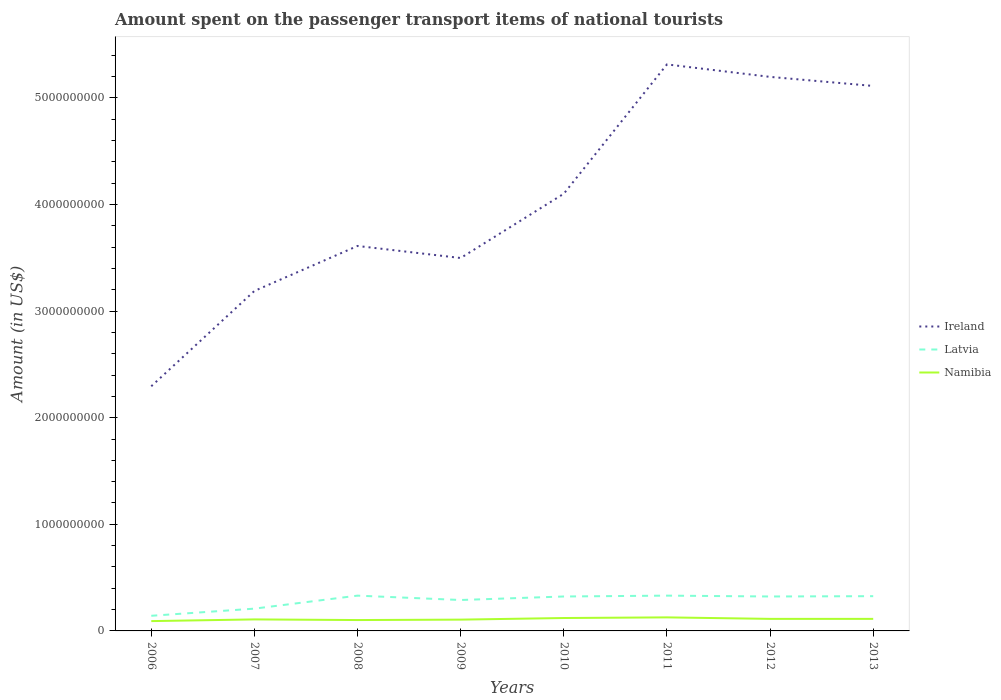Does the line corresponding to Ireland intersect with the line corresponding to Latvia?
Keep it short and to the point. No. Is the number of lines equal to the number of legend labels?
Make the answer very short. Yes. Across all years, what is the maximum amount spent on the passenger transport items of national tourists in Ireland?
Give a very brief answer. 2.30e+09. What is the total amount spent on the passenger transport items of national tourists in Latvia in the graph?
Give a very brief answer. -1.89e+08. What is the difference between the highest and the second highest amount spent on the passenger transport items of national tourists in Ireland?
Offer a very short reply. 3.02e+09. What is the difference between the highest and the lowest amount spent on the passenger transport items of national tourists in Namibia?
Ensure brevity in your answer.  4. How many lines are there?
Ensure brevity in your answer.  3. How many years are there in the graph?
Your response must be concise. 8. Does the graph contain any zero values?
Provide a short and direct response. No. Where does the legend appear in the graph?
Make the answer very short. Center right. How many legend labels are there?
Make the answer very short. 3. How are the legend labels stacked?
Keep it short and to the point. Vertical. What is the title of the graph?
Provide a succinct answer. Amount spent on the passenger transport items of national tourists. Does "Suriname" appear as one of the legend labels in the graph?
Give a very brief answer. No. What is the label or title of the Y-axis?
Your response must be concise. Amount (in US$). What is the Amount (in US$) of Ireland in 2006?
Your answer should be very brief. 2.30e+09. What is the Amount (in US$) in Latvia in 2006?
Make the answer very short. 1.42e+08. What is the Amount (in US$) of Namibia in 2006?
Provide a short and direct response. 9.20e+07. What is the Amount (in US$) of Ireland in 2007?
Your response must be concise. 3.19e+09. What is the Amount (in US$) in Latvia in 2007?
Ensure brevity in your answer.  2.09e+08. What is the Amount (in US$) of Namibia in 2007?
Make the answer very short. 1.08e+08. What is the Amount (in US$) in Ireland in 2008?
Your response must be concise. 3.61e+09. What is the Amount (in US$) in Latvia in 2008?
Keep it short and to the point. 3.31e+08. What is the Amount (in US$) of Namibia in 2008?
Make the answer very short. 1.02e+08. What is the Amount (in US$) in Ireland in 2009?
Provide a succinct answer. 3.50e+09. What is the Amount (in US$) of Latvia in 2009?
Give a very brief answer. 2.90e+08. What is the Amount (in US$) in Namibia in 2009?
Provide a succinct answer. 1.06e+08. What is the Amount (in US$) of Ireland in 2010?
Your answer should be very brief. 4.10e+09. What is the Amount (in US$) of Latvia in 2010?
Offer a very short reply. 3.23e+08. What is the Amount (in US$) in Namibia in 2010?
Make the answer very short. 1.21e+08. What is the Amount (in US$) in Ireland in 2011?
Keep it short and to the point. 5.31e+09. What is the Amount (in US$) in Latvia in 2011?
Ensure brevity in your answer.  3.31e+08. What is the Amount (in US$) in Namibia in 2011?
Your answer should be compact. 1.27e+08. What is the Amount (in US$) of Ireland in 2012?
Make the answer very short. 5.20e+09. What is the Amount (in US$) of Latvia in 2012?
Provide a short and direct response. 3.23e+08. What is the Amount (in US$) in Namibia in 2012?
Ensure brevity in your answer.  1.13e+08. What is the Amount (in US$) in Ireland in 2013?
Keep it short and to the point. 5.11e+09. What is the Amount (in US$) in Latvia in 2013?
Provide a succinct answer. 3.26e+08. What is the Amount (in US$) in Namibia in 2013?
Give a very brief answer. 1.13e+08. Across all years, what is the maximum Amount (in US$) in Ireland?
Your answer should be compact. 5.31e+09. Across all years, what is the maximum Amount (in US$) of Latvia?
Your answer should be very brief. 3.31e+08. Across all years, what is the maximum Amount (in US$) of Namibia?
Give a very brief answer. 1.27e+08. Across all years, what is the minimum Amount (in US$) in Ireland?
Provide a short and direct response. 2.30e+09. Across all years, what is the minimum Amount (in US$) of Latvia?
Your answer should be very brief. 1.42e+08. Across all years, what is the minimum Amount (in US$) in Namibia?
Keep it short and to the point. 9.20e+07. What is the total Amount (in US$) of Ireland in the graph?
Your answer should be compact. 3.23e+1. What is the total Amount (in US$) of Latvia in the graph?
Your answer should be very brief. 2.28e+09. What is the total Amount (in US$) in Namibia in the graph?
Ensure brevity in your answer.  8.82e+08. What is the difference between the Amount (in US$) in Ireland in 2006 and that in 2007?
Offer a terse response. -8.94e+08. What is the difference between the Amount (in US$) of Latvia in 2006 and that in 2007?
Your response must be concise. -6.70e+07. What is the difference between the Amount (in US$) of Namibia in 2006 and that in 2007?
Your response must be concise. -1.60e+07. What is the difference between the Amount (in US$) in Ireland in 2006 and that in 2008?
Make the answer very short. -1.32e+09. What is the difference between the Amount (in US$) in Latvia in 2006 and that in 2008?
Ensure brevity in your answer.  -1.89e+08. What is the difference between the Amount (in US$) of Namibia in 2006 and that in 2008?
Ensure brevity in your answer.  -1.00e+07. What is the difference between the Amount (in US$) in Ireland in 2006 and that in 2009?
Make the answer very short. -1.20e+09. What is the difference between the Amount (in US$) of Latvia in 2006 and that in 2009?
Ensure brevity in your answer.  -1.48e+08. What is the difference between the Amount (in US$) of Namibia in 2006 and that in 2009?
Your response must be concise. -1.40e+07. What is the difference between the Amount (in US$) in Ireland in 2006 and that in 2010?
Make the answer very short. -1.81e+09. What is the difference between the Amount (in US$) of Latvia in 2006 and that in 2010?
Give a very brief answer. -1.81e+08. What is the difference between the Amount (in US$) in Namibia in 2006 and that in 2010?
Keep it short and to the point. -2.90e+07. What is the difference between the Amount (in US$) of Ireland in 2006 and that in 2011?
Offer a terse response. -3.02e+09. What is the difference between the Amount (in US$) of Latvia in 2006 and that in 2011?
Your answer should be compact. -1.89e+08. What is the difference between the Amount (in US$) in Namibia in 2006 and that in 2011?
Make the answer very short. -3.50e+07. What is the difference between the Amount (in US$) in Ireland in 2006 and that in 2012?
Provide a short and direct response. -2.90e+09. What is the difference between the Amount (in US$) in Latvia in 2006 and that in 2012?
Give a very brief answer. -1.81e+08. What is the difference between the Amount (in US$) of Namibia in 2006 and that in 2012?
Keep it short and to the point. -2.10e+07. What is the difference between the Amount (in US$) of Ireland in 2006 and that in 2013?
Provide a short and direct response. -2.82e+09. What is the difference between the Amount (in US$) of Latvia in 2006 and that in 2013?
Keep it short and to the point. -1.84e+08. What is the difference between the Amount (in US$) in Namibia in 2006 and that in 2013?
Keep it short and to the point. -2.10e+07. What is the difference between the Amount (in US$) of Ireland in 2007 and that in 2008?
Ensure brevity in your answer.  -4.22e+08. What is the difference between the Amount (in US$) in Latvia in 2007 and that in 2008?
Make the answer very short. -1.22e+08. What is the difference between the Amount (in US$) in Namibia in 2007 and that in 2008?
Offer a terse response. 6.00e+06. What is the difference between the Amount (in US$) in Ireland in 2007 and that in 2009?
Your answer should be very brief. -3.09e+08. What is the difference between the Amount (in US$) in Latvia in 2007 and that in 2009?
Provide a succinct answer. -8.10e+07. What is the difference between the Amount (in US$) of Ireland in 2007 and that in 2010?
Provide a short and direct response. -9.12e+08. What is the difference between the Amount (in US$) of Latvia in 2007 and that in 2010?
Offer a very short reply. -1.14e+08. What is the difference between the Amount (in US$) in Namibia in 2007 and that in 2010?
Keep it short and to the point. -1.30e+07. What is the difference between the Amount (in US$) of Ireland in 2007 and that in 2011?
Your answer should be compact. -2.12e+09. What is the difference between the Amount (in US$) of Latvia in 2007 and that in 2011?
Offer a very short reply. -1.22e+08. What is the difference between the Amount (in US$) in Namibia in 2007 and that in 2011?
Provide a succinct answer. -1.90e+07. What is the difference between the Amount (in US$) of Ireland in 2007 and that in 2012?
Make the answer very short. -2.01e+09. What is the difference between the Amount (in US$) in Latvia in 2007 and that in 2012?
Make the answer very short. -1.14e+08. What is the difference between the Amount (in US$) of Namibia in 2007 and that in 2012?
Provide a short and direct response. -5.00e+06. What is the difference between the Amount (in US$) of Ireland in 2007 and that in 2013?
Offer a very short reply. -1.92e+09. What is the difference between the Amount (in US$) in Latvia in 2007 and that in 2013?
Provide a succinct answer. -1.17e+08. What is the difference between the Amount (in US$) in Namibia in 2007 and that in 2013?
Provide a short and direct response. -5.00e+06. What is the difference between the Amount (in US$) of Ireland in 2008 and that in 2009?
Make the answer very short. 1.13e+08. What is the difference between the Amount (in US$) in Latvia in 2008 and that in 2009?
Keep it short and to the point. 4.10e+07. What is the difference between the Amount (in US$) in Namibia in 2008 and that in 2009?
Make the answer very short. -4.00e+06. What is the difference between the Amount (in US$) of Ireland in 2008 and that in 2010?
Your answer should be very brief. -4.90e+08. What is the difference between the Amount (in US$) in Namibia in 2008 and that in 2010?
Make the answer very short. -1.90e+07. What is the difference between the Amount (in US$) of Ireland in 2008 and that in 2011?
Ensure brevity in your answer.  -1.70e+09. What is the difference between the Amount (in US$) of Namibia in 2008 and that in 2011?
Make the answer very short. -2.50e+07. What is the difference between the Amount (in US$) of Ireland in 2008 and that in 2012?
Your answer should be compact. -1.59e+09. What is the difference between the Amount (in US$) in Namibia in 2008 and that in 2012?
Ensure brevity in your answer.  -1.10e+07. What is the difference between the Amount (in US$) of Ireland in 2008 and that in 2013?
Ensure brevity in your answer.  -1.50e+09. What is the difference between the Amount (in US$) of Latvia in 2008 and that in 2013?
Make the answer very short. 5.00e+06. What is the difference between the Amount (in US$) in Namibia in 2008 and that in 2013?
Your response must be concise. -1.10e+07. What is the difference between the Amount (in US$) in Ireland in 2009 and that in 2010?
Ensure brevity in your answer.  -6.03e+08. What is the difference between the Amount (in US$) in Latvia in 2009 and that in 2010?
Give a very brief answer. -3.30e+07. What is the difference between the Amount (in US$) of Namibia in 2009 and that in 2010?
Provide a succinct answer. -1.50e+07. What is the difference between the Amount (in US$) in Ireland in 2009 and that in 2011?
Provide a succinct answer. -1.82e+09. What is the difference between the Amount (in US$) in Latvia in 2009 and that in 2011?
Offer a terse response. -4.10e+07. What is the difference between the Amount (in US$) of Namibia in 2009 and that in 2011?
Keep it short and to the point. -2.10e+07. What is the difference between the Amount (in US$) of Ireland in 2009 and that in 2012?
Offer a terse response. -1.70e+09. What is the difference between the Amount (in US$) of Latvia in 2009 and that in 2012?
Your answer should be compact. -3.30e+07. What is the difference between the Amount (in US$) in Namibia in 2009 and that in 2012?
Give a very brief answer. -7.00e+06. What is the difference between the Amount (in US$) of Ireland in 2009 and that in 2013?
Your answer should be compact. -1.61e+09. What is the difference between the Amount (in US$) of Latvia in 2009 and that in 2013?
Your response must be concise. -3.60e+07. What is the difference between the Amount (in US$) of Namibia in 2009 and that in 2013?
Your response must be concise. -7.00e+06. What is the difference between the Amount (in US$) in Ireland in 2010 and that in 2011?
Keep it short and to the point. -1.21e+09. What is the difference between the Amount (in US$) of Latvia in 2010 and that in 2011?
Ensure brevity in your answer.  -8.00e+06. What is the difference between the Amount (in US$) in Namibia in 2010 and that in 2011?
Your answer should be compact. -6.00e+06. What is the difference between the Amount (in US$) in Ireland in 2010 and that in 2012?
Keep it short and to the point. -1.10e+09. What is the difference between the Amount (in US$) in Latvia in 2010 and that in 2012?
Ensure brevity in your answer.  0. What is the difference between the Amount (in US$) of Ireland in 2010 and that in 2013?
Your answer should be very brief. -1.01e+09. What is the difference between the Amount (in US$) in Latvia in 2010 and that in 2013?
Offer a terse response. -3.00e+06. What is the difference between the Amount (in US$) of Ireland in 2011 and that in 2012?
Provide a succinct answer. 1.17e+08. What is the difference between the Amount (in US$) of Latvia in 2011 and that in 2012?
Your response must be concise. 8.00e+06. What is the difference between the Amount (in US$) of Namibia in 2011 and that in 2012?
Provide a short and direct response. 1.40e+07. What is the difference between the Amount (in US$) in Ireland in 2011 and that in 2013?
Offer a very short reply. 2.02e+08. What is the difference between the Amount (in US$) of Latvia in 2011 and that in 2013?
Give a very brief answer. 5.00e+06. What is the difference between the Amount (in US$) of Namibia in 2011 and that in 2013?
Offer a very short reply. 1.40e+07. What is the difference between the Amount (in US$) of Ireland in 2012 and that in 2013?
Your answer should be compact. 8.50e+07. What is the difference between the Amount (in US$) in Latvia in 2012 and that in 2013?
Your answer should be compact. -3.00e+06. What is the difference between the Amount (in US$) in Ireland in 2006 and the Amount (in US$) in Latvia in 2007?
Make the answer very short. 2.09e+09. What is the difference between the Amount (in US$) in Ireland in 2006 and the Amount (in US$) in Namibia in 2007?
Your answer should be compact. 2.19e+09. What is the difference between the Amount (in US$) in Latvia in 2006 and the Amount (in US$) in Namibia in 2007?
Make the answer very short. 3.40e+07. What is the difference between the Amount (in US$) in Ireland in 2006 and the Amount (in US$) in Latvia in 2008?
Provide a short and direct response. 1.96e+09. What is the difference between the Amount (in US$) of Ireland in 2006 and the Amount (in US$) of Namibia in 2008?
Your response must be concise. 2.19e+09. What is the difference between the Amount (in US$) in Latvia in 2006 and the Amount (in US$) in Namibia in 2008?
Provide a succinct answer. 4.00e+07. What is the difference between the Amount (in US$) in Ireland in 2006 and the Amount (in US$) in Latvia in 2009?
Give a very brief answer. 2.00e+09. What is the difference between the Amount (in US$) in Ireland in 2006 and the Amount (in US$) in Namibia in 2009?
Keep it short and to the point. 2.19e+09. What is the difference between the Amount (in US$) of Latvia in 2006 and the Amount (in US$) of Namibia in 2009?
Make the answer very short. 3.60e+07. What is the difference between the Amount (in US$) of Ireland in 2006 and the Amount (in US$) of Latvia in 2010?
Offer a terse response. 1.97e+09. What is the difference between the Amount (in US$) of Ireland in 2006 and the Amount (in US$) of Namibia in 2010?
Provide a succinct answer. 2.17e+09. What is the difference between the Amount (in US$) of Latvia in 2006 and the Amount (in US$) of Namibia in 2010?
Offer a very short reply. 2.10e+07. What is the difference between the Amount (in US$) in Ireland in 2006 and the Amount (in US$) in Latvia in 2011?
Give a very brief answer. 1.96e+09. What is the difference between the Amount (in US$) of Ireland in 2006 and the Amount (in US$) of Namibia in 2011?
Provide a short and direct response. 2.17e+09. What is the difference between the Amount (in US$) of Latvia in 2006 and the Amount (in US$) of Namibia in 2011?
Offer a very short reply. 1.50e+07. What is the difference between the Amount (in US$) in Ireland in 2006 and the Amount (in US$) in Latvia in 2012?
Provide a short and direct response. 1.97e+09. What is the difference between the Amount (in US$) of Ireland in 2006 and the Amount (in US$) of Namibia in 2012?
Give a very brief answer. 2.18e+09. What is the difference between the Amount (in US$) in Latvia in 2006 and the Amount (in US$) in Namibia in 2012?
Offer a terse response. 2.90e+07. What is the difference between the Amount (in US$) in Ireland in 2006 and the Amount (in US$) in Latvia in 2013?
Make the answer very short. 1.97e+09. What is the difference between the Amount (in US$) of Ireland in 2006 and the Amount (in US$) of Namibia in 2013?
Keep it short and to the point. 2.18e+09. What is the difference between the Amount (in US$) in Latvia in 2006 and the Amount (in US$) in Namibia in 2013?
Give a very brief answer. 2.90e+07. What is the difference between the Amount (in US$) of Ireland in 2007 and the Amount (in US$) of Latvia in 2008?
Give a very brief answer. 2.86e+09. What is the difference between the Amount (in US$) in Ireland in 2007 and the Amount (in US$) in Namibia in 2008?
Your answer should be very brief. 3.09e+09. What is the difference between the Amount (in US$) of Latvia in 2007 and the Amount (in US$) of Namibia in 2008?
Provide a short and direct response. 1.07e+08. What is the difference between the Amount (in US$) of Ireland in 2007 and the Amount (in US$) of Latvia in 2009?
Your answer should be very brief. 2.90e+09. What is the difference between the Amount (in US$) of Ireland in 2007 and the Amount (in US$) of Namibia in 2009?
Ensure brevity in your answer.  3.08e+09. What is the difference between the Amount (in US$) of Latvia in 2007 and the Amount (in US$) of Namibia in 2009?
Your response must be concise. 1.03e+08. What is the difference between the Amount (in US$) in Ireland in 2007 and the Amount (in US$) in Latvia in 2010?
Your response must be concise. 2.87e+09. What is the difference between the Amount (in US$) of Ireland in 2007 and the Amount (in US$) of Namibia in 2010?
Give a very brief answer. 3.07e+09. What is the difference between the Amount (in US$) of Latvia in 2007 and the Amount (in US$) of Namibia in 2010?
Ensure brevity in your answer.  8.80e+07. What is the difference between the Amount (in US$) of Ireland in 2007 and the Amount (in US$) of Latvia in 2011?
Your answer should be compact. 2.86e+09. What is the difference between the Amount (in US$) in Ireland in 2007 and the Amount (in US$) in Namibia in 2011?
Ensure brevity in your answer.  3.06e+09. What is the difference between the Amount (in US$) in Latvia in 2007 and the Amount (in US$) in Namibia in 2011?
Provide a short and direct response. 8.20e+07. What is the difference between the Amount (in US$) of Ireland in 2007 and the Amount (in US$) of Latvia in 2012?
Provide a short and direct response. 2.87e+09. What is the difference between the Amount (in US$) in Ireland in 2007 and the Amount (in US$) in Namibia in 2012?
Your answer should be very brief. 3.08e+09. What is the difference between the Amount (in US$) in Latvia in 2007 and the Amount (in US$) in Namibia in 2012?
Your response must be concise. 9.60e+07. What is the difference between the Amount (in US$) of Ireland in 2007 and the Amount (in US$) of Latvia in 2013?
Offer a very short reply. 2.86e+09. What is the difference between the Amount (in US$) in Ireland in 2007 and the Amount (in US$) in Namibia in 2013?
Offer a very short reply. 3.08e+09. What is the difference between the Amount (in US$) of Latvia in 2007 and the Amount (in US$) of Namibia in 2013?
Your answer should be very brief. 9.60e+07. What is the difference between the Amount (in US$) of Ireland in 2008 and the Amount (in US$) of Latvia in 2009?
Your answer should be compact. 3.32e+09. What is the difference between the Amount (in US$) in Ireland in 2008 and the Amount (in US$) in Namibia in 2009?
Offer a very short reply. 3.50e+09. What is the difference between the Amount (in US$) of Latvia in 2008 and the Amount (in US$) of Namibia in 2009?
Your answer should be compact. 2.25e+08. What is the difference between the Amount (in US$) of Ireland in 2008 and the Amount (in US$) of Latvia in 2010?
Ensure brevity in your answer.  3.29e+09. What is the difference between the Amount (in US$) of Ireland in 2008 and the Amount (in US$) of Namibia in 2010?
Give a very brief answer. 3.49e+09. What is the difference between the Amount (in US$) of Latvia in 2008 and the Amount (in US$) of Namibia in 2010?
Give a very brief answer. 2.10e+08. What is the difference between the Amount (in US$) of Ireland in 2008 and the Amount (in US$) of Latvia in 2011?
Offer a terse response. 3.28e+09. What is the difference between the Amount (in US$) in Ireland in 2008 and the Amount (in US$) in Namibia in 2011?
Provide a succinct answer. 3.48e+09. What is the difference between the Amount (in US$) in Latvia in 2008 and the Amount (in US$) in Namibia in 2011?
Offer a very short reply. 2.04e+08. What is the difference between the Amount (in US$) of Ireland in 2008 and the Amount (in US$) of Latvia in 2012?
Your answer should be very brief. 3.29e+09. What is the difference between the Amount (in US$) of Ireland in 2008 and the Amount (in US$) of Namibia in 2012?
Provide a short and direct response. 3.50e+09. What is the difference between the Amount (in US$) in Latvia in 2008 and the Amount (in US$) in Namibia in 2012?
Your response must be concise. 2.18e+08. What is the difference between the Amount (in US$) in Ireland in 2008 and the Amount (in US$) in Latvia in 2013?
Provide a succinct answer. 3.28e+09. What is the difference between the Amount (in US$) in Ireland in 2008 and the Amount (in US$) in Namibia in 2013?
Make the answer very short. 3.50e+09. What is the difference between the Amount (in US$) of Latvia in 2008 and the Amount (in US$) of Namibia in 2013?
Make the answer very short. 2.18e+08. What is the difference between the Amount (in US$) in Ireland in 2009 and the Amount (in US$) in Latvia in 2010?
Ensure brevity in your answer.  3.18e+09. What is the difference between the Amount (in US$) of Ireland in 2009 and the Amount (in US$) of Namibia in 2010?
Ensure brevity in your answer.  3.38e+09. What is the difference between the Amount (in US$) in Latvia in 2009 and the Amount (in US$) in Namibia in 2010?
Make the answer very short. 1.69e+08. What is the difference between the Amount (in US$) of Ireland in 2009 and the Amount (in US$) of Latvia in 2011?
Offer a very short reply. 3.17e+09. What is the difference between the Amount (in US$) in Ireland in 2009 and the Amount (in US$) in Namibia in 2011?
Give a very brief answer. 3.37e+09. What is the difference between the Amount (in US$) of Latvia in 2009 and the Amount (in US$) of Namibia in 2011?
Your answer should be compact. 1.63e+08. What is the difference between the Amount (in US$) of Ireland in 2009 and the Amount (in US$) of Latvia in 2012?
Your response must be concise. 3.18e+09. What is the difference between the Amount (in US$) of Ireland in 2009 and the Amount (in US$) of Namibia in 2012?
Your response must be concise. 3.38e+09. What is the difference between the Amount (in US$) in Latvia in 2009 and the Amount (in US$) in Namibia in 2012?
Your answer should be very brief. 1.77e+08. What is the difference between the Amount (in US$) in Ireland in 2009 and the Amount (in US$) in Latvia in 2013?
Offer a very short reply. 3.17e+09. What is the difference between the Amount (in US$) of Ireland in 2009 and the Amount (in US$) of Namibia in 2013?
Provide a succinct answer. 3.38e+09. What is the difference between the Amount (in US$) of Latvia in 2009 and the Amount (in US$) of Namibia in 2013?
Offer a very short reply. 1.77e+08. What is the difference between the Amount (in US$) in Ireland in 2010 and the Amount (in US$) in Latvia in 2011?
Make the answer very short. 3.77e+09. What is the difference between the Amount (in US$) of Ireland in 2010 and the Amount (in US$) of Namibia in 2011?
Provide a short and direct response. 3.97e+09. What is the difference between the Amount (in US$) in Latvia in 2010 and the Amount (in US$) in Namibia in 2011?
Ensure brevity in your answer.  1.96e+08. What is the difference between the Amount (in US$) in Ireland in 2010 and the Amount (in US$) in Latvia in 2012?
Provide a short and direct response. 3.78e+09. What is the difference between the Amount (in US$) in Ireland in 2010 and the Amount (in US$) in Namibia in 2012?
Keep it short and to the point. 3.99e+09. What is the difference between the Amount (in US$) of Latvia in 2010 and the Amount (in US$) of Namibia in 2012?
Give a very brief answer. 2.10e+08. What is the difference between the Amount (in US$) of Ireland in 2010 and the Amount (in US$) of Latvia in 2013?
Offer a very short reply. 3.78e+09. What is the difference between the Amount (in US$) of Ireland in 2010 and the Amount (in US$) of Namibia in 2013?
Keep it short and to the point. 3.99e+09. What is the difference between the Amount (in US$) of Latvia in 2010 and the Amount (in US$) of Namibia in 2013?
Provide a succinct answer. 2.10e+08. What is the difference between the Amount (in US$) of Ireland in 2011 and the Amount (in US$) of Latvia in 2012?
Provide a short and direct response. 4.99e+09. What is the difference between the Amount (in US$) in Ireland in 2011 and the Amount (in US$) in Namibia in 2012?
Offer a terse response. 5.20e+09. What is the difference between the Amount (in US$) of Latvia in 2011 and the Amount (in US$) of Namibia in 2012?
Your answer should be compact. 2.18e+08. What is the difference between the Amount (in US$) of Ireland in 2011 and the Amount (in US$) of Latvia in 2013?
Offer a very short reply. 4.99e+09. What is the difference between the Amount (in US$) of Ireland in 2011 and the Amount (in US$) of Namibia in 2013?
Offer a terse response. 5.20e+09. What is the difference between the Amount (in US$) in Latvia in 2011 and the Amount (in US$) in Namibia in 2013?
Offer a very short reply. 2.18e+08. What is the difference between the Amount (in US$) of Ireland in 2012 and the Amount (in US$) of Latvia in 2013?
Ensure brevity in your answer.  4.87e+09. What is the difference between the Amount (in US$) of Ireland in 2012 and the Amount (in US$) of Namibia in 2013?
Make the answer very short. 5.08e+09. What is the difference between the Amount (in US$) of Latvia in 2012 and the Amount (in US$) of Namibia in 2013?
Offer a very short reply. 2.10e+08. What is the average Amount (in US$) in Ireland per year?
Give a very brief answer. 4.04e+09. What is the average Amount (in US$) of Latvia per year?
Offer a terse response. 2.84e+08. What is the average Amount (in US$) of Namibia per year?
Offer a very short reply. 1.10e+08. In the year 2006, what is the difference between the Amount (in US$) in Ireland and Amount (in US$) in Latvia?
Your answer should be very brief. 2.15e+09. In the year 2006, what is the difference between the Amount (in US$) of Ireland and Amount (in US$) of Namibia?
Make the answer very short. 2.20e+09. In the year 2007, what is the difference between the Amount (in US$) in Ireland and Amount (in US$) in Latvia?
Your answer should be very brief. 2.98e+09. In the year 2007, what is the difference between the Amount (in US$) of Ireland and Amount (in US$) of Namibia?
Offer a terse response. 3.08e+09. In the year 2007, what is the difference between the Amount (in US$) of Latvia and Amount (in US$) of Namibia?
Your answer should be compact. 1.01e+08. In the year 2008, what is the difference between the Amount (in US$) of Ireland and Amount (in US$) of Latvia?
Your answer should be very brief. 3.28e+09. In the year 2008, what is the difference between the Amount (in US$) in Ireland and Amount (in US$) in Namibia?
Ensure brevity in your answer.  3.51e+09. In the year 2008, what is the difference between the Amount (in US$) in Latvia and Amount (in US$) in Namibia?
Ensure brevity in your answer.  2.29e+08. In the year 2009, what is the difference between the Amount (in US$) in Ireland and Amount (in US$) in Latvia?
Provide a short and direct response. 3.21e+09. In the year 2009, what is the difference between the Amount (in US$) of Ireland and Amount (in US$) of Namibia?
Your answer should be very brief. 3.39e+09. In the year 2009, what is the difference between the Amount (in US$) in Latvia and Amount (in US$) in Namibia?
Offer a terse response. 1.84e+08. In the year 2010, what is the difference between the Amount (in US$) of Ireland and Amount (in US$) of Latvia?
Give a very brief answer. 3.78e+09. In the year 2010, what is the difference between the Amount (in US$) in Ireland and Amount (in US$) in Namibia?
Make the answer very short. 3.98e+09. In the year 2010, what is the difference between the Amount (in US$) of Latvia and Amount (in US$) of Namibia?
Your response must be concise. 2.02e+08. In the year 2011, what is the difference between the Amount (in US$) of Ireland and Amount (in US$) of Latvia?
Your answer should be very brief. 4.98e+09. In the year 2011, what is the difference between the Amount (in US$) of Ireland and Amount (in US$) of Namibia?
Your response must be concise. 5.19e+09. In the year 2011, what is the difference between the Amount (in US$) of Latvia and Amount (in US$) of Namibia?
Offer a very short reply. 2.04e+08. In the year 2012, what is the difference between the Amount (in US$) in Ireland and Amount (in US$) in Latvia?
Your answer should be very brief. 4.87e+09. In the year 2012, what is the difference between the Amount (in US$) of Ireland and Amount (in US$) of Namibia?
Ensure brevity in your answer.  5.08e+09. In the year 2012, what is the difference between the Amount (in US$) in Latvia and Amount (in US$) in Namibia?
Offer a terse response. 2.10e+08. In the year 2013, what is the difference between the Amount (in US$) in Ireland and Amount (in US$) in Latvia?
Provide a short and direct response. 4.79e+09. In the year 2013, what is the difference between the Amount (in US$) of Ireland and Amount (in US$) of Namibia?
Make the answer very short. 5.00e+09. In the year 2013, what is the difference between the Amount (in US$) of Latvia and Amount (in US$) of Namibia?
Your answer should be compact. 2.13e+08. What is the ratio of the Amount (in US$) of Ireland in 2006 to that in 2007?
Offer a very short reply. 0.72. What is the ratio of the Amount (in US$) of Latvia in 2006 to that in 2007?
Offer a terse response. 0.68. What is the ratio of the Amount (in US$) in Namibia in 2006 to that in 2007?
Provide a short and direct response. 0.85. What is the ratio of the Amount (in US$) in Ireland in 2006 to that in 2008?
Offer a very short reply. 0.64. What is the ratio of the Amount (in US$) of Latvia in 2006 to that in 2008?
Offer a terse response. 0.43. What is the ratio of the Amount (in US$) in Namibia in 2006 to that in 2008?
Provide a succinct answer. 0.9. What is the ratio of the Amount (in US$) of Ireland in 2006 to that in 2009?
Your answer should be very brief. 0.66. What is the ratio of the Amount (in US$) in Latvia in 2006 to that in 2009?
Offer a very short reply. 0.49. What is the ratio of the Amount (in US$) of Namibia in 2006 to that in 2009?
Keep it short and to the point. 0.87. What is the ratio of the Amount (in US$) in Ireland in 2006 to that in 2010?
Provide a succinct answer. 0.56. What is the ratio of the Amount (in US$) in Latvia in 2006 to that in 2010?
Your answer should be compact. 0.44. What is the ratio of the Amount (in US$) in Namibia in 2006 to that in 2010?
Your answer should be very brief. 0.76. What is the ratio of the Amount (in US$) of Ireland in 2006 to that in 2011?
Provide a short and direct response. 0.43. What is the ratio of the Amount (in US$) of Latvia in 2006 to that in 2011?
Keep it short and to the point. 0.43. What is the ratio of the Amount (in US$) in Namibia in 2006 to that in 2011?
Provide a short and direct response. 0.72. What is the ratio of the Amount (in US$) of Ireland in 2006 to that in 2012?
Your response must be concise. 0.44. What is the ratio of the Amount (in US$) in Latvia in 2006 to that in 2012?
Ensure brevity in your answer.  0.44. What is the ratio of the Amount (in US$) of Namibia in 2006 to that in 2012?
Keep it short and to the point. 0.81. What is the ratio of the Amount (in US$) in Ireland in 2006 to that in 2013?
Provide a succinct answer. 0.45. What is the ratio of the Amount (in US$) of Latvia in 2006 to that in 2013?
Offer a terse response. 0.44. What is the ratio of the Amount (in US$) of Namibia in 2006 to that in 2013?
Your response must be concise. 0.81. What is the ratio of the Amount (in US$) of Ireland in 2007 to that in 2008?
Make the answer very short. 0.88. What is the ratio of the Amount (in US$) of Latvia in 2007 to that in 2008?
Offer a terse response. 0.63. What is the ratio of the Amount (in US$) of Namibia in 2007 to that in 2008?
Make the answer very short. 1.06. What is the ratio of the Amount (in US$) in Ireland in 2007 to that in 2009?
Offer a terse response. 0.91. What is the ratio of the Amount (in US$) in Latvia in 2007 to that in 2009?
Offer a terse response. 0.72. What is the ratio of the Amount (in US$) in Namibia in 2007 to that in 2009?
Offer a very short reply. 1.02. What is the ratio of the Amount (in US$) in Ireland in 2007 to that in 2010?
Offer a very short reply. 0.78. What is the ratio of the Amount (in US$) of Latvia in 2007 to that in 2010?
Provide a short and direct response. 0.65. What is the ratio of the Amount (in US$) of Namibia in 2007 to that in 2010?
Make the answer very short. 0.89. What is the ratio of the Amount (in US$) of Ireland in 2007 to that in 2011?
Your response must be concise. 0.6. What is the ratio of the Amount (in US$) in Latvia in 2007 to that in 2011?
Keep it short and to the point. 0.63. What is the ratio of the Amount (in US$) of Namibia in 2007 to that in 2011?
Give a very brief answer. 0.85. What is the ratio of the Amount (in US$) of Ireland in 2007 to that in 2012?
Provide a short and direct response. 0.61. What is the ratio of the Amount (in US$) of Latvia in 2007 to that in 2012?
Your answer should be compact. 0.65. What is the ratio of the Amount (in US$) of Namibia in 2007 to that in 2012?
Your answer should be compact. 0.96. What is the ratio of the Amount (in US$) in Ireland in 2007 to that in 2013?
Keep it short and to the point. 0.62. What is the ratio of the Amount (in US$) of Latvia in 2007 to that in 2013?
Provide a succinct answer. 0.64. What is the ratio of the Amount (in US$) in Namibia in 2007 to that in 2013?
Offer a very short reply. 0.96. What is the ratio of the Amount (in US$) of Ireland in 2008 to that in 2009?
Your answer should be compact. 1.03. What is the ratio of the Amount (in US$) in Latvia in 2008 to that in 2009?
Give a very brief answer. 1.14. What is the ratio of the Amount (in US$) of Namibia in 2008 to that in 2009?
Offer a very short reply. 0.96. What is the ratio of the Amount (in US$) in Ireland in 2008 to that in 2010?
Your answer should be compact. 0.88. What is the ratio of the Amount (in US$) in Latvia in 2008 to that in 2010?
Your response must be concise. 1.02. What is the ratio of the Amount (in US$) of Namibia in 2008 to that in 2010?
Ensure brevity in your answer.  0.84. What is the ratio of the Amount (in US$) in Ireland in 2008 to that in 2011?
Give a very brief answer. 0.68. What is the ratio of the Amount (in US$) in Namibia in 2008 to that in 2011?
Make the answer very short. 0.8. What is the ratio of the Amount (in US$) of Ireland in 2008 to that in 2012?
Offer a terse response. 0.69. What is the ratio of the Amount (in US$) of Latvia in 2008 to that in 2012?
Offer a terse response. 1.02. What is the ratio of the Amount (in US$) in Namibia in 2008 to that in 2012?
Provide a short and direct response. 0.9. What is the ratio of the Amount (in US$) of Ireland in 2008 to that in 2013?
Provide a succinct answer. 0.71. What is the ratio of the Amount (in US$) in Latvia in 2008 to that in 2013?
Provide a succinct answer. 1.02. What is the ratio of the Amount (in US$) of Namibia in 2008 to that in 2013?
Keep it short and to the point. 0.9. What is the ratio of the Amount (in US$) in Ireland in 2009 to that in 2010?
Provide a short and direct response. 0.85. What is the ratio of the Amount (in US$) in Latvia in 2009 to that in 2010?
Offer a very short reply. 0.9. What is the ratio of the Amount (in US$) in Namibia in 2009 to that in 2010?
Offer a terse response. 0.88. What is the ratio of the Amount (in US$) of Ireland in 2009 to that in 2011?
Give a very brief answer. 0.66. What is the ratio of the Amount (in US$) in Latvia in 2009 to that in 2011?
Make the answer very short. 0.88. What is the ratio of the Amount (in US$) in Namibia in 2009 to that in 2011?
Your answer should be compact. 0.83. What is the ratio of the Amount (in US$) in Ireland in 2009 to that in 2012?
Make the answer very short. 0.67. What is the ratio of the Amount (in US$) in Latvia in 2009 to that in 2012?
Make the answer very short. 0.9. What is the ratio of the Amount (in US$) of Namibia in 2009 to that in 2012?
Offer a very short reply. 0.94. What is the ratio of the Amount (in US$) of Ireland in 2009 to that in 2013?
Your answer should be very brief. 0.68. What is the ratio of the Amount (in US$) in Latvia in 2009 to that in 2013?
Provide a succinct answer. 0.89. What is the ratio of the Amount (in US$) in Namibia in 2009 to that in 2013?
Provide a short and direct response. 0.94. What is the ratio of the Amount (in US$) of Ireland in 2010 to that in 2011?
Your response must be concise. 0.77. What is the ratio of the Amount (in US$) in Latvia in 2010 to that in 2011?
Provide a short and direct response. 0.98. What is the ratio of the Amount (in US$) of Namibia in 2010 to that in 2011?
Provide a short and direct response. 0.95. What is the ratio of the Amount (in US$) in Ireland in 2010 to that in 2012?
Provide a succinct answer. 0.79. What is the ratio of the Amount (in US$) of Namibia in 2010 to that in 2012?
Provide a short and direct response. 1.07. What is the ratio of the Amount (in US$) in Ireland in 2010 to that in 2013?
Give a very brief answer. 0.8. What is the ratio of the Amount (in US$) of Latvia in 2010 to that in 2013?
Offer a terse response. 0.99. What is the ratio of the Amount (in US$) in Namibia in 2010 to that in 2013?
Keep it short and to the point. 1.07. What is the ratio of the Amount (in US$) of Ireland in 2011 to that in 2012?
Ensure brevity in your answer.  1.02. What is the ratio of the Amount (in US$) of Latvia in 2011 to that in 2012?
Give a very brief answer. 1.02. What is the ratio of the Amount (in US$) in Namibia in 2011 to that in 2012?
Make the answer very short. 1.12. What is the ratio of the Amount (in US$) in Ireland in 2011 to that in 2013?
Offer a terse response. 1.04. What is the ratio of the Amount (in US$) of Latvia in 2011 to that in 2013?
Make the answer very short. 1.02. What is the ratio of the Amount (in US$) in Namibia in 2011 to that in 2013?
Your answer should be very brief. 1.12. What is the ratio of the Amount (in US$) of Ireland in 2012 to that in 2013?
Your answer should be very brief. 1.02. What is the difference between the highest and the second highest Amount (in US$) of Ireland?
Provide a short and direct response. 1.17e+08. What is the difference between the highest and the second highest Amount (in US$) of Namibia?
Your response must be concise. 6.00e+06. What is the difference between the highest and the lowest Amount (in US$) in Ireland?
Your answer should be compact. 3.02e+09. What is the difference between the highest and the lowest Amount (in US$) in Latvia?
Ensure brevity in your answer.  1.89e+08. What is the difference between the highest and the lowest Amount (in US$) in Namibia?
Your answer should be very brief. 3.50e+07. 